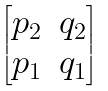Convert formula to latex. <formula><loc_0><loc_0><loc_500><loc_500>\begin{bmatrix} p _ { 2 } & q _ { 2 } \\ p _ { 1 } & q _ { 1 } \end{bmatrix}</formula> 